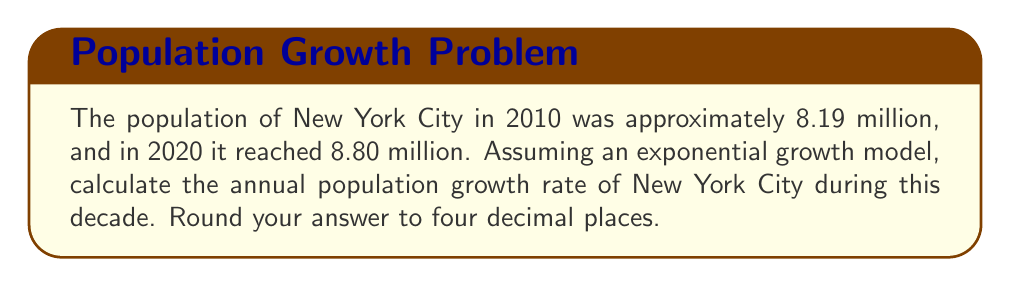Give your solution to this math problem. To solve this problem, we'll use the exponential growth model:

$$P(t) = P_0 e^{rt}$$

Where:
$P(t)$ is the population at time $t$
$P_0$ is the initial population
$r$ is the annual growth rate
$t$ is the time in years

We know:
$P_0 = 8.19$ million (population in 2010)
$P(10) = 8.80$ million (population in 2020)
$t = 10$ years

Let's substitute these values into the equation:

$$8.80 = 8.19 e^{10r}$$

Now, we need to solve for $r$:

1) Divide both sides by 8.19:
   $$\frac{8.80}{8.19} = e^{10r}$$

2) Take the natural logarithm of both sides:
   $$\ln(\frac{8.80}{8.19}) = \ln(e^{10r})$$

3) Simplify the right side:
   $$\ln(\frac{8.80}{8.19}) = 10r$$

4) Divide both sides by 10:
   $$\frac{\ln(\frac{8.80}{8.19})}{10} = r$$

5) Calculate the value:
   $$r = \frac{\ln(1.0744811965)}{10} = 0.0071799$$

6) Round to four decimal places:
   $$r \approx 0.0072$$
Answer: The annual population growth rate of New York City from 2010 to 2020 was approximately 0.0072 or 0.72%. 